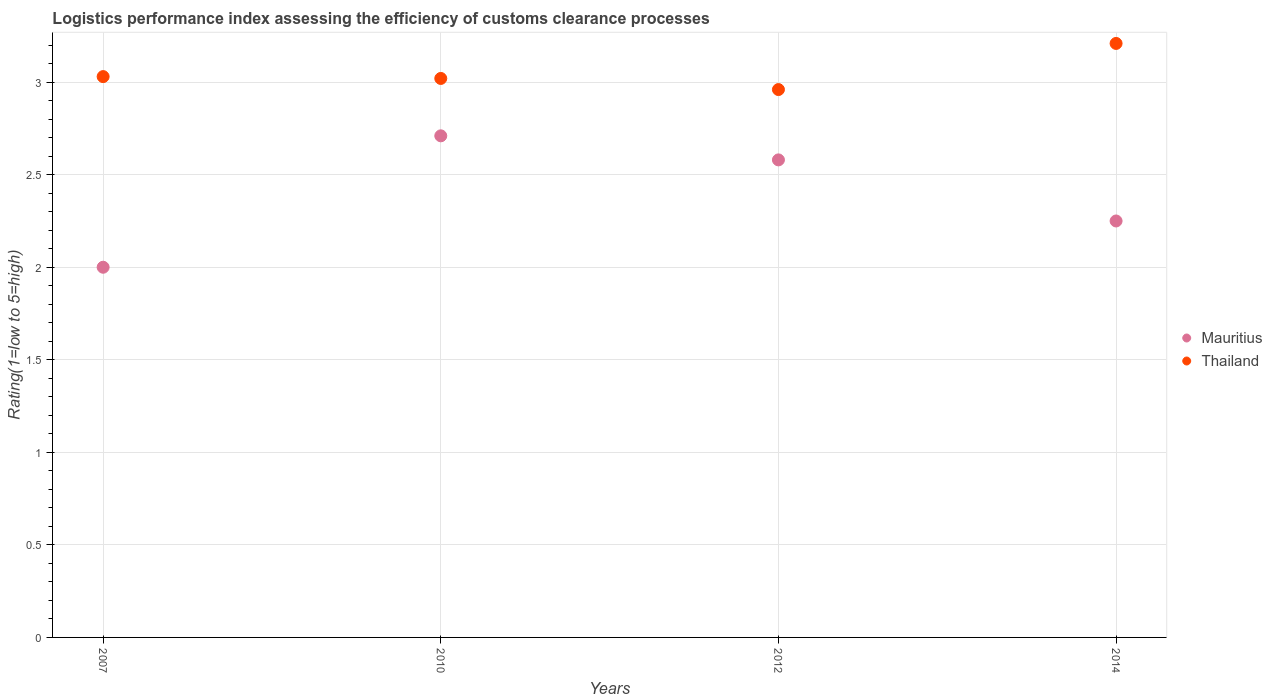How many different coloured dotlines are there?
Your answer should be compact. 2. What is the Logistic performance index in Thailand in 2007?
Keep it short and to the point. 3.03. Across all years, what is the maximum Logistic performance index in Mauritius?
Give a very brief answer. 2.71. Across all years, what is the minimum Logistic performance index in Thailand?
Provide a succinct answer. 2.96. In which year was the Logistic performance index in Mauritius minimum?
Provide a succinct answer. 2007. What is the total Logistic performance index in Mauritius in the graph?
Provide a succinct answer. 9.54. What is the difference between the Logistic performance index in Thailand in 2012 and that in 2014?
Keep it short and to the point. -0.25. What is the difference between the Logistic performance index in Thailand in 2014 and the Logistic performance index in Mauritius in 2007?
Your answer should be very brief. 1.21. What is the average Logistic performance index in Thailand per year?
Provide a succinct answer. 3.05. In the year 2010, what is the difference between the Logistic performance index in Thailand and Logistic performance index in Mauritius?
Your answer should be very brief. 0.31. What is the ratio of the Logistic performance index in Thailand in 2012 to that in 2014?
Provide a short and direct response. 0.92. Is the Logistic performance index in Mauritius in 2012 less than that in 2014?
Give a very brief answer. No. What is the difference between the highest and the second highest Logistic performance index in Mauritius?
Keep it short and to the point. 0.13. What is the difference between the highest and the lowest Logistic performance index in Thailand?
Make the answer very short. 0.25. In how many years, is the Logistic performance index in Mauritius greater than the average Logistic performance index in Mauritius taken over all years?
Your answer should be very brief. 2. Is the Logistic performance index in Thailand strictly greater than the Logistic performance index in Mauritius over the years?
Your response must be concise. Yes. How many dotlines are there?
Make the answer very short. 2. How many years are there in the graph?
Ensure brevity in your answer.  4. What is the difference between two consecutive major ticks on the Y-axis?
Make the answer very short. 0.5. Are the values on the major ticks of Y-axis written in scientific E-notation?
Keep it short and to the point. No. Does the graph contain any zero values?
Offer a very short reply. No. Does the graph contain grids?
Provide a succinct answer. Yes. Where does the legend appear in the graph?
Provide a short and direct response. Center right. What is the title of the graph?
Provide a succinct answer. Logistics performance index assessing the efficiency of customs clearance processes. Does "Cameroon" appear as one of the legend labels in the graph?
Your answer should be compact. No. What is the label or title of the Y-axis?
Your answer should be very brief. Rating(1=low to 5=high). What is the Rating(1=low to 5=high) of Thailand in 2007?
Offer a very short reply. 3.03. What is the Rating(1=low to 5=high) in Mauritius in 2010?
Offer a terse response. 2.71. What is the Rating(1=low to 5=high) in Thailand in 2010?
Your response must be concise. 3.02. What is the Rating(1=low to 5=high) in Mauritius in 2012?
Your answer should be very brief. 2.58. What is the Rating(1=low to 5=high) in Thailand in 2012?
Keep it short and to the point. 2.96. What is the Rating(1=low to 5=high) in Mauritius in 2014?
Offer a terse response. 2.25. What is the Rating(1=low to 5=high) in Thailand in 2014?
Keep it short and to the point. 3.21. Across all years, what is the maximum Rating(1=low to 5=high) of Mauritius?
Your answer should be compact. 2.71. Across all years, what is the maximum Rating(1=low to 5=high) in Thailand?
Offer a very short reply. 3.21. Across all years, what is the minimum Rating(1=low to 5=high) in Mauritius?
Your answer should be very brief. 2. Across all years, what is the minimum Rating(1=low to 5=high) of Thailand?
Keep it short and to the point. 2.96. What is the total Rating(1=low to 5=high) in Mauritius in the graph?
Your answer should be compact. 9.54. What is the total Rating(1=low to 5=high) of Thailand in the graph?
Keep it short and to the point. 12.22. What is the difference between the Rating(1=low to 5=high) of Mauritius in 2007 and that in 2010?
Offer a very short reply. -0.71. What is the difference between the Rating(1=low to 5=high) of Mauritius in 2007 and that in 2012?
Your response must be concise. -0.58. What is the difference between the Rating(1=low to 5=high) in Thailand in 2007 and that in 2012?
Offer a very short reply. 0.07. What is the difference between the Rating(1=low to 5=high) of Mauritius in 2007 and that in 2014?
Your answer should be very brief. -0.25. What is the difference between the Rating(1=low to 5=high) of Thailand in 2007 and that in 2014?
Make the answer very short. -0.18. What is the difference between the Rating(1=low to 5=high) in Mauritius in 2010 and that in 2012?
Your response must be concise. 0.13. What is the difference between the Rating(1=low to 5=high) in Mauritius in 2010 and that in 2014?
Keep it short and to the point. 0.46. What is the difference between the Rating(1=low to 5=high) in Thailand in 2010 and that in 2014?
Provide a short and direct response. -0.19. What is the difference between the Rating(1=low to 5=high) of Mauritius in 2012 and that in 2014?
Your answer should be very brief. 0.33. What is the difference between the Rating(1=low to 5=high) of Thailand in 2012 and that in 2014?
Your answer should be very brief. -0.25. What is the difference between the Rating(1=low to 5=high) in Mauritius in 2007 and the Rating(1=low to 5=high) in Thailand in 2010?
Provide a succinct answer. -1.02. What is the difference between the Rating(1=low to 5=high) in Mauritius in 2007 and the Rating(1=low to 5=high) in Thailand in 2012?
Offer a terse response. -0.96. What is the difference between the Rating(1=low to 5=high) in Mauritius in 2007 and the Rating(1=low to 5=high) in Thailand in 2014?
Your answer should be compact. -1.21. What is the difference between the Rating(1=low to 5=high) of Mauritius in 2010 and the Rating(1=low to 5=high) of Thailand in 2014?
Provide a succinct answer. -0.5. What is the difference between the Rating(1=low to 5=high) in Mauritius in 2012 and the Rating(1=low to 5=high) in Thailand in 2014?
Provide a succinct answer. -0.63. What is the average Rating(1=low to 5=high) of Mauritius per year?
Give a very brief answer. 2.38. What is the average Rating(1=low to 5=high) in Thailand per year?
Your answer should be compact. 3.05. In the year 2007, what is the difference between the Rating(1=low to 5=high) in Mauritius and Rating(1=low to 5=high) in Thailand?
Your answer should be compact. -1.03. In the year 2010, what is the difference between the Rating(1=low to 5=high) in Mauritius and Rating(1=low to 5=high) in Thailand?
Make the answer very short. -0.31. In the year 2012, what is the difference between the Rating(1=low to 5=high) in Mauritius and Rating(1=low to 5=high) in Thailand?
Provide a short and direct response. -0.38. In the year 2014, what is the difference between the Rating(1=low to 5=high) in Mauritius and Rating(1=low to 5=high) in Thailand?
Keep it short and to the point. -0.96. What is the ratio of the Rating(1=low to 5=high) in Mauritius in 2007 to that in 2010?
Offer a very short reply. 0.74. What is the ratio of the Rating(1=low to 5=high) in Thailand in 2007 to that in 2010?
Provide a succinct answer. 1. What is the ratio of the Rating(1=low to 5=high) in Mauritius in 2007 to that in 2012?
Your answer should be compact. 0.78. What is the ratio of the Rating(1=low to 5=high) in Thailand in 2007 to that in 2012?
Your answer should be compact. 1.02. What is the ratio of the Rating(1=low to 5=high) of Mauritius in 2007 to that in 2014?
Keep it short and to the point. 0.89. What is the ratio of the Rating(1=low to 5=high) in Thailand in 2007 to that in 2014?
Your response must be concise. 0.94. What is the ratio of the Rating(1=low to 5=high) of Mauritius in 2010 to that in 2012?
Provide a succinct answer. 1.05. What is the ratio of the Rating(1=low to 5=high) in Thailand in 2010 to that in 2012?
Your answer should be very brief. 1.02. What is the ratio of the Rating(1=low to 5=high) in Mauritius in 2010 to that in 2014?
Your answer should be very brief. 1.2. What is the ratio of the Rating(1=low to 5=high) in Thailand in 2010 to that in 2014?
Give a very brief answer. 0.94. What is the ratio of the Rating(1=low to 5=high) of Mauritius in 2012 to that in 2014?
Provide a short and direct response. 1.15. What is the ratio of the Rating(1=low to 5=high) of Thailand in 2012 to that in 2014?
Your response must be concise. 0.92. What is the difference between the highest and the second highest Rating(1=low to 5=high) in Mauritius?
Make the answer very short. 0.13. What is the difference between the highest and the second highest Rating(1=low to 5=high) of Thailand?
Your answer should be compact. 0.18. What is the difference between the highest and the lowest Rating(1=low to 5=high) in Mauritius?
Your response must be concise. 0.71. What is the difference between the highest and the lowest Rating(1=low to 5=high) of Thailand?
Provide a succinct answer. 0.25. 